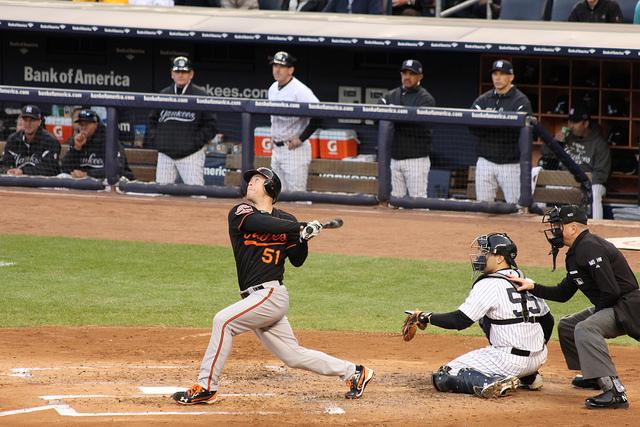What is the event occurring?
Give a very brief answer. Baseball. How many teams are shown in this image?
Answer briefly. 2. What number is the umpire?
Keep it brief. 0. 